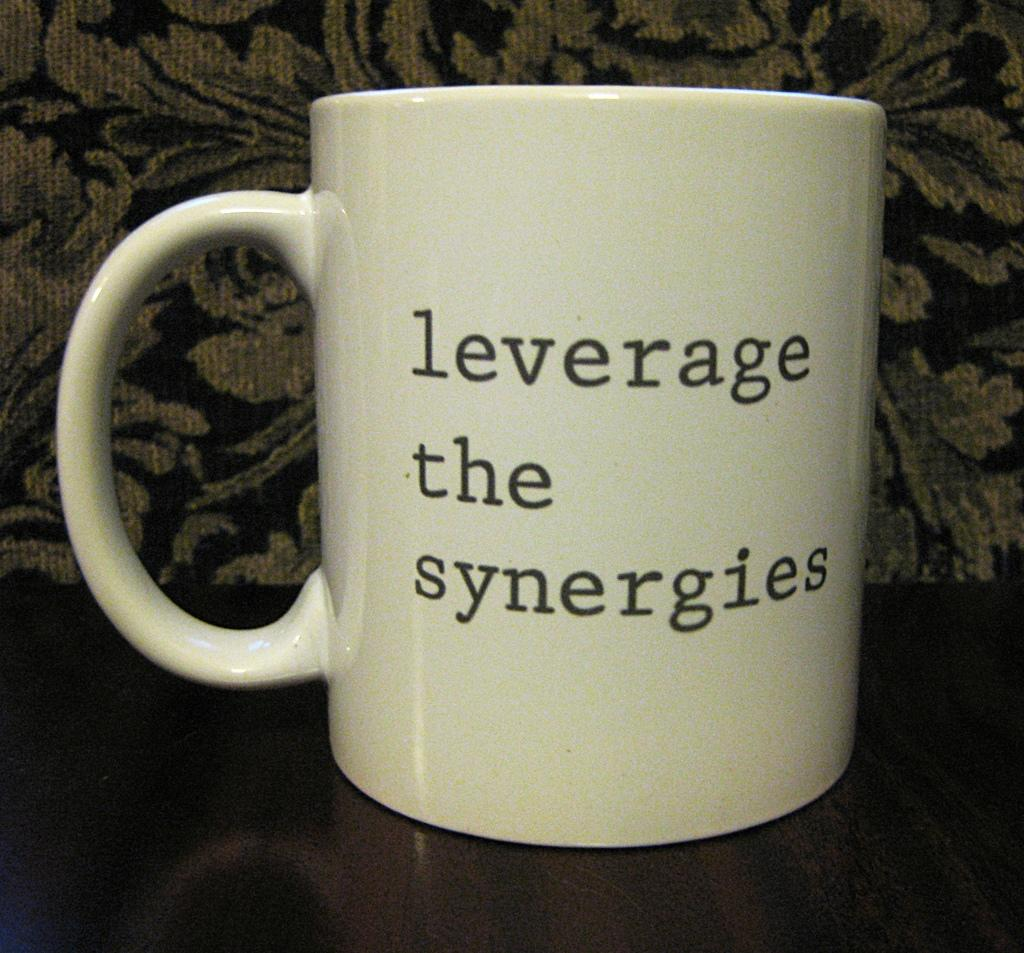<image>
Provide a brief description of the given image. The beige coffee cup says "Leverage the synergies". 